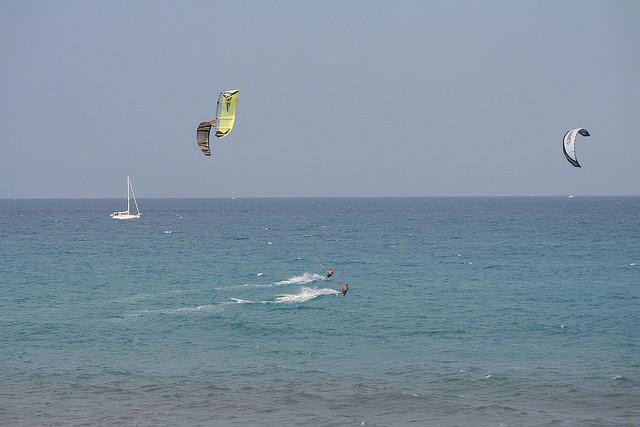How many boats do you see?
Give a very brief answer. 1. 